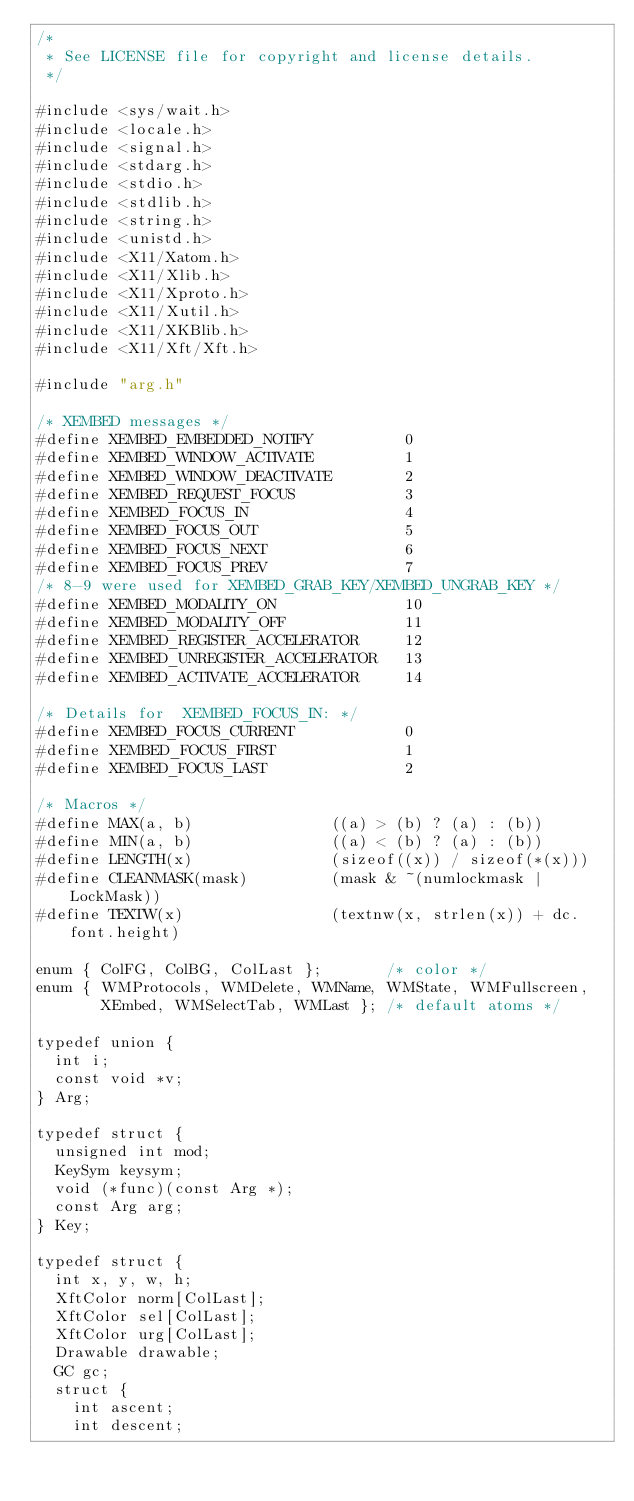<code> <loc_0><loc_0><loc_500><loc_500><_C_>/*
 * See LICENSE file for copyright and license details.
 */

#include <sys/wait.h>
#include <locale.h>
#include <signal.h>
#include <stdarg.h>
#include <stdio.h>
#include <stdlib.h>
#include <string.h>
#include <unistd.h>
#include <X11/Xatom.h>
#include <X11/Xlib.h>
#include <X11/Xproto.h>
#include <X11/Xutil.h>
#include <X11/XKBlib.h>
#include <X11/Xft/Xft.h>

#include "arg.h"

/* XEMBED messages */
#define XEMBED_EMBEDDED_NOTIFY          0
#define XEMBED_WINDOW_ACTIVATE          1
#define XEMBED_WINDOW_DEACTIVATE        2
#define XEMBED_REQUEST_FOCUS            3
#define XEMBED_FOCUS_IN                 4
#define XEMBED_FOCUS_OUT                5
#define XEMBED_FOCUS_NEXT               6
#define XEMBED_FOCUS_PREV               7
/* 8-9 were used for XEMBED_GRAB_KEY/XEMBED_UNGRAB_KEY */
#define XEMBED_MODALITY_ON              10
#define XEMBED_MODALITY_OFF             11
#define XEMBED_REGISTER_ACCELERATOR     12
#define XEMBED_UNREGISTER_ACCELERATOR   13
#define XEMBED_ACTIVATE_ACCELERATOR     14

/* Details for  XEMBED_FOCUS_IN: */
#define XEMBED_FOCUS_CURRENT            0
#define XEMBED_FOCUS_FIRST              1
#define XEMBED_FOCUS_LAST               2

/* Macros */
#define MAX(a, b)               ((a) > (b) ? (a) : (b))
#define MIN(a, b)               ((a) < (b) ? (a) : (b))
#define LENGTH(x)               (sizeof((x)) / sizeof(*(x)))
#define CLEANMASK(mask)         (mask & ~(numlockmask | LockMask))
#define TEXTW(x)                (textnw(x, strlen(x)) + dc.font.height)

enum { ColFG, ColBG, ColLast };       /* color */
enum { WMProtocols, WMDelete, WMName, WMState, WMFullscreen,
       XEmbed, WMSelectTab, WMLast }; /* default atoms */

typedef union {
	int i;
	const void *v;
} Arg;

typedef struct {
	unsigned int mod;
	KeySym keysym;
	void (*func)(const Arg *);
	const Arg arg;
} Key;

typedef struct {
	int x, y, w, h;
	XftColor norm[ColLast];
	XftColor sel[ColLast];
	XftColor urg[ColLast];
	Drawable drawable;
	GC gc;
	struct {
		int ascent;
		int descent;</code> 